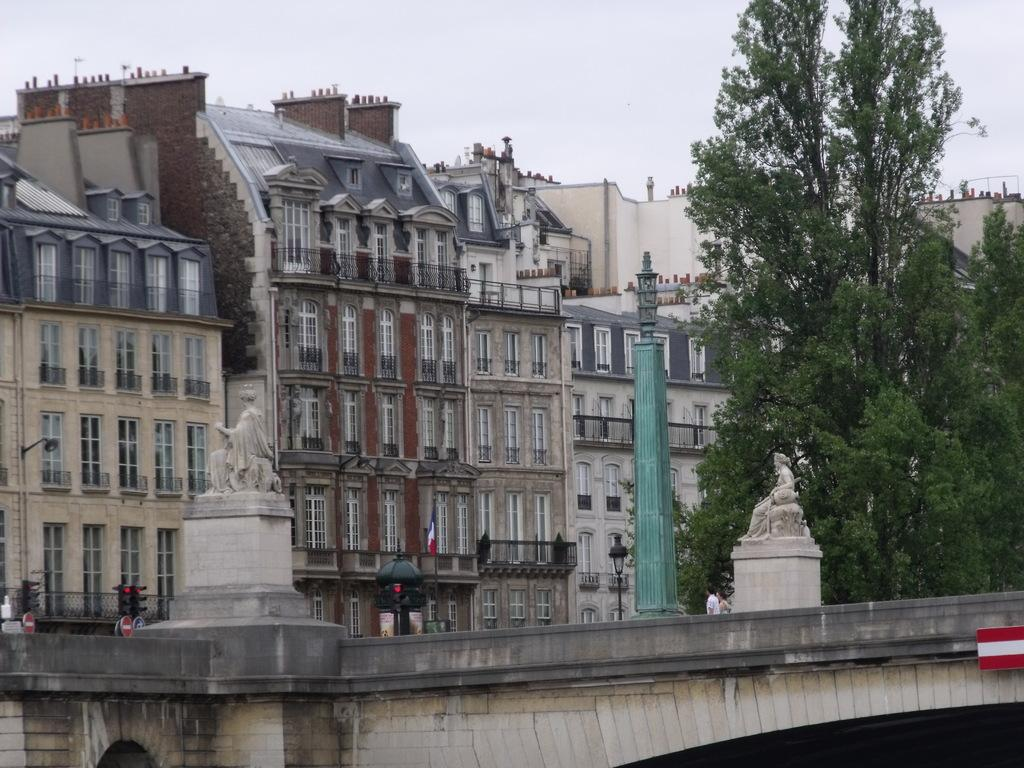What type of structures can be seen in the image? There are buildings in the image. What architectural elements are present in the image? There are pillars in the image. What type of lighting is present in the image? There are street lights in the image. Are there any sculptures in the image? Yes, there are statues in the image. What type of vegetation is present in the image? There are trees in the image. What type of infrastructure is present in the image? There is a bridge in the image. What type of traffic control is present in the image? There are traffic signals in the image. Are there any people in the image? Yes, there are persons in the image. What part of the natural environment is visible in the image? The sky is visible in the image. Can you tell me how many pages of the book are visible in the image? There is no book present in the image, so it is not possible to determine the number of pages visible. What type of goat can be seen grazing in the image? There is no goat present in the image. What type of art is displayed on the bridge in the image? There is no art displayed on the bridge in the image. 